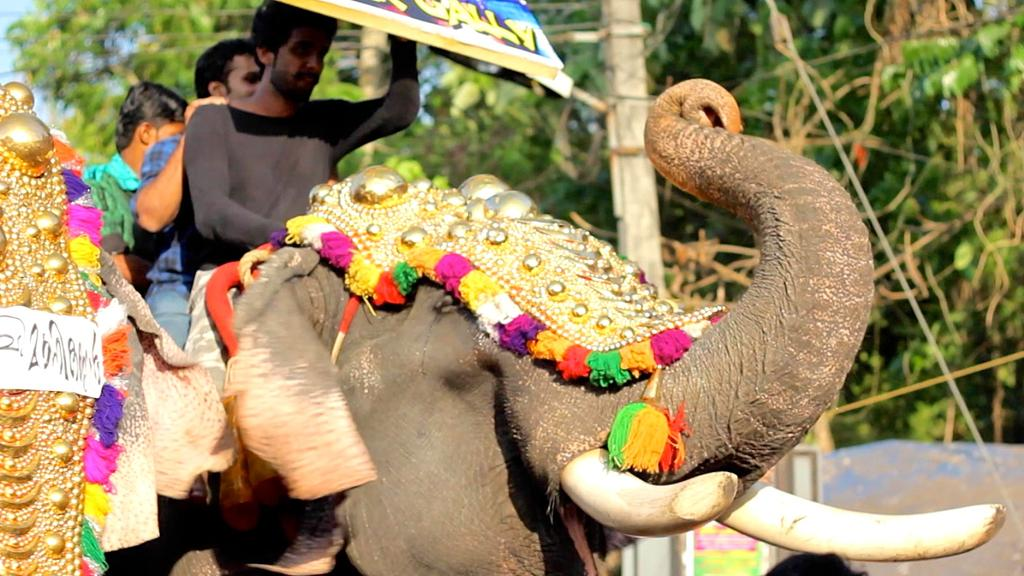How many people are in the image? There are three people in the image. What are the people doing in the image? The people are sitting on an elephant. What is the man in the front holding? The man in the front is holding a hoarding. What can be seen in the background of the image? There is a tree in the background of the image. What type of range can be seen in the image? There is no range present in the image; it features three people sitting on an elephant. Can you tell me how many children are playing in the image? There is no mention of children playing in the image; it only shows three people sitting on an elephant. 